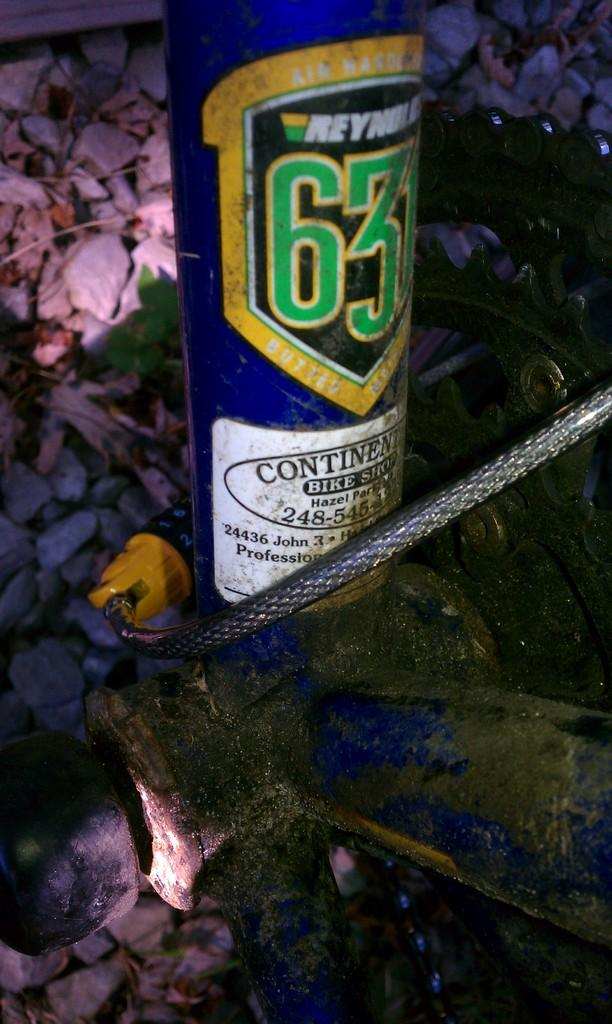What object is partially visible in the image? There is a partial part of a bicycle in the image. What can be seen in the background of the image? There are stones, leaves, and twigs in the background of the image. What type of creature is holding the crate in the image? There is no crate or creature present in the image. 